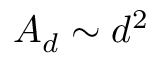Convert formula to latex. <formula><loc_0><loc_0><loc_500><loc_500>A _ { d } \sim d ^ { 2 }</formula> 